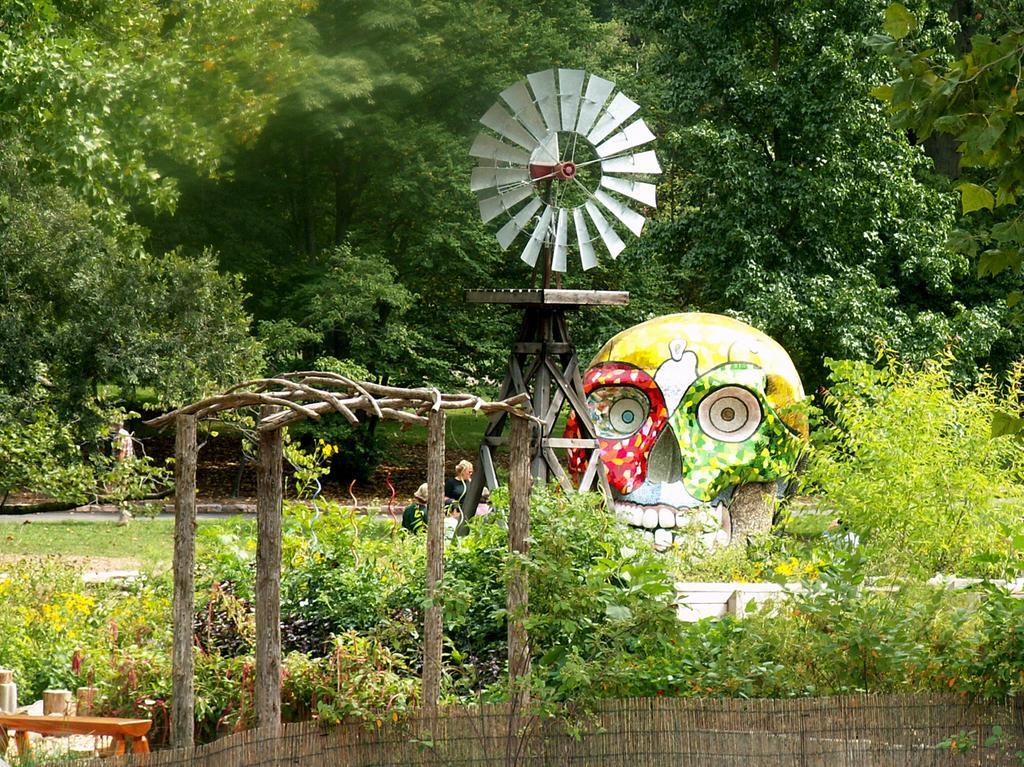Please provide a concise description of this image. In this image I can see number of plants, number of trees, a red and green colour skull. I can also see windmill and few people over here. 